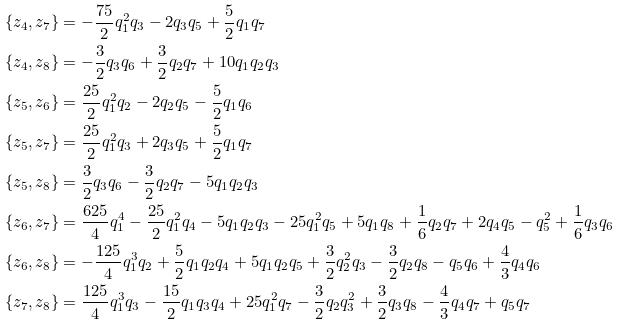Convert formula to latex. <formula><loc_0><loc_0><loc_500><loc_500>\{ z _ { 4 } , z _ { 7 } \} & = - \frac { 7 5 } { 2 } q _ { 1 } ^ { 2 } q _ { 3 } - 2 q _ { 3 } q _ { 5 } + \frac { 5 } { 2 } q _ { 1 } q _ { 7 } \\ \{ z _ { 4 } , z _ { 8 } \} & = - \frac { 3 } { 2 } q _ { 3 } q _ { 6 } + \frac { 3 } { 2 } q _ { 2 } q _ { 7 } + 1 0 q _ { 1 } q _ { 2 } q _ { 3 } \\ \{ z _ { 5 } , z _ { 6 } \} & = \frac { 2 5 } { 2 } q _ { 1 } ^ { 2 } q _ { 2 } - 2 q _ { 2 } q _ { 5 } - \frac { 5 } { 2 } q _ { 1 } q _ { 6 } \\ \{ z _ { 5 } , z _ { 7 } \} & = \frac { 2 5 } { 2 } q _ { 1 } ^ { 2 } q _ { 3 } + 2 q _ { 3 } q _ { 5 } + \frac { 5 } { 2 } q _ { 1 } q _ { 7 } \\ \{ z _ { 5 } , z _ { 8 } \} & = \frac { 3 } { 2 } q _ { 3 } q _ { 6 } - \frac { 3 } { 2 } q _ { 2 } q _ { 7 } - 5 q _ { 1 } q _ { 2 } q _ { 3 } \\ \{ z _ { 6 } , z _ { 7 } \} & = \frac { 6 2 5 } { 4 } q _ { 1 } ^ { 4 } - \frac { 2 5 } { 2 } q _ { 1 } ^ { 2 } q _ { 4 } - 5 q _ { 1 } q _ { 2 } q _ { 3 } - 2 5 q _ { 1 } ^ { 2 } q _ { 5 } + 5 q _ { 1 } q _ { 8 } + \frac { 1 } { 6 } q _ { 2 } q _ { 7 } + 2 q _ { 4 } q _ { 5 } - q _ { 5 } ^ { 2 } + \frac { 1 } { 6 } q _ { 3 } q _ { 6 } \\ \{ z _ { 6 } , z _ { 8 } \} & = - \frac { 1 2 5 } { 4 } q _ { 1 } ^ { 3 } q _ { 2 } + \frac { 5 } { 2 } q _ { 1 } q _ { 2 } q _ { 4 } + 5 q _ { 1 } q _ { 2 } q _ { 5 } + \frac { 3 } { 2 } q _ { 2 } ^ { 2 } q _ { 3 } - \frac { 3 } { 2 } q _ { 2 } q _ { 8 } - q _ { 5 } q _ { 6 } + \frac { 4 } { 3 } q _ { 4 } q _ { 6 } \\ \{ z _ { 7 } , z _ { 8 } \} & = \frac { 1 2 5 } { 4 } q _ { 1 } ^ { 3 } q _ { 3 } - \frac { 1 5 } { 2 } q _ { 1 } q _ { 3 } q _ { 4 } + 2 5 q _ { 1 } ^ { 2 } q _ { 7 } - \frac { 3 } { 2 } q _ { 2 } q _ { 3 } ^ { 2 } + \frac { 3 } { 2 } q _ { 3 } q _ { 8 } - \frac { 4 } { 3 } q _ { 4 } q _ { 7 } + q _ { 5 } q _ { 7 }</formula> 